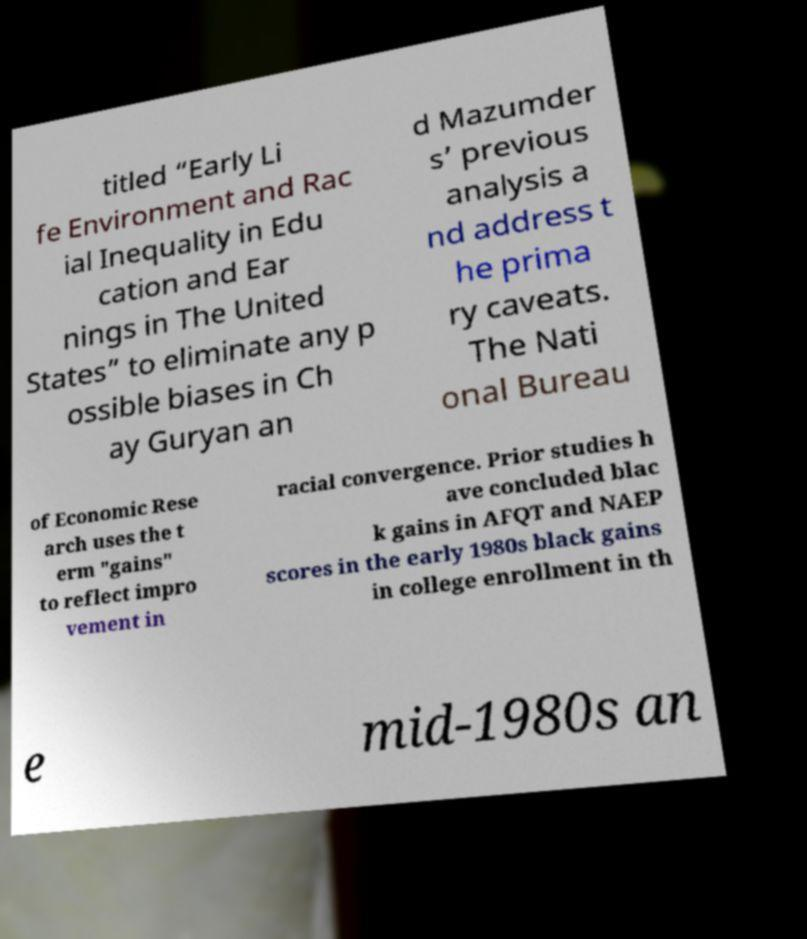Please identify and transcribe the text found in this image. titled “Early Li fe Environment and Rac ial Inequality in Edu cation and Ear nings in The United States” to eliminate any p ossible biases in Ch ay Guryan an d Mazumder s’ previous analysis a nd address t he prima ry caveats. The Nati onal Bureau of Economic Rese arch uses the t erm "gains" to reflect impro vement in racial convergence. Prior studies h ave concluded blac k gains in AFQT and NAEP scores in the early 1980s black gains in college enrollment in th e mid-1980s an 